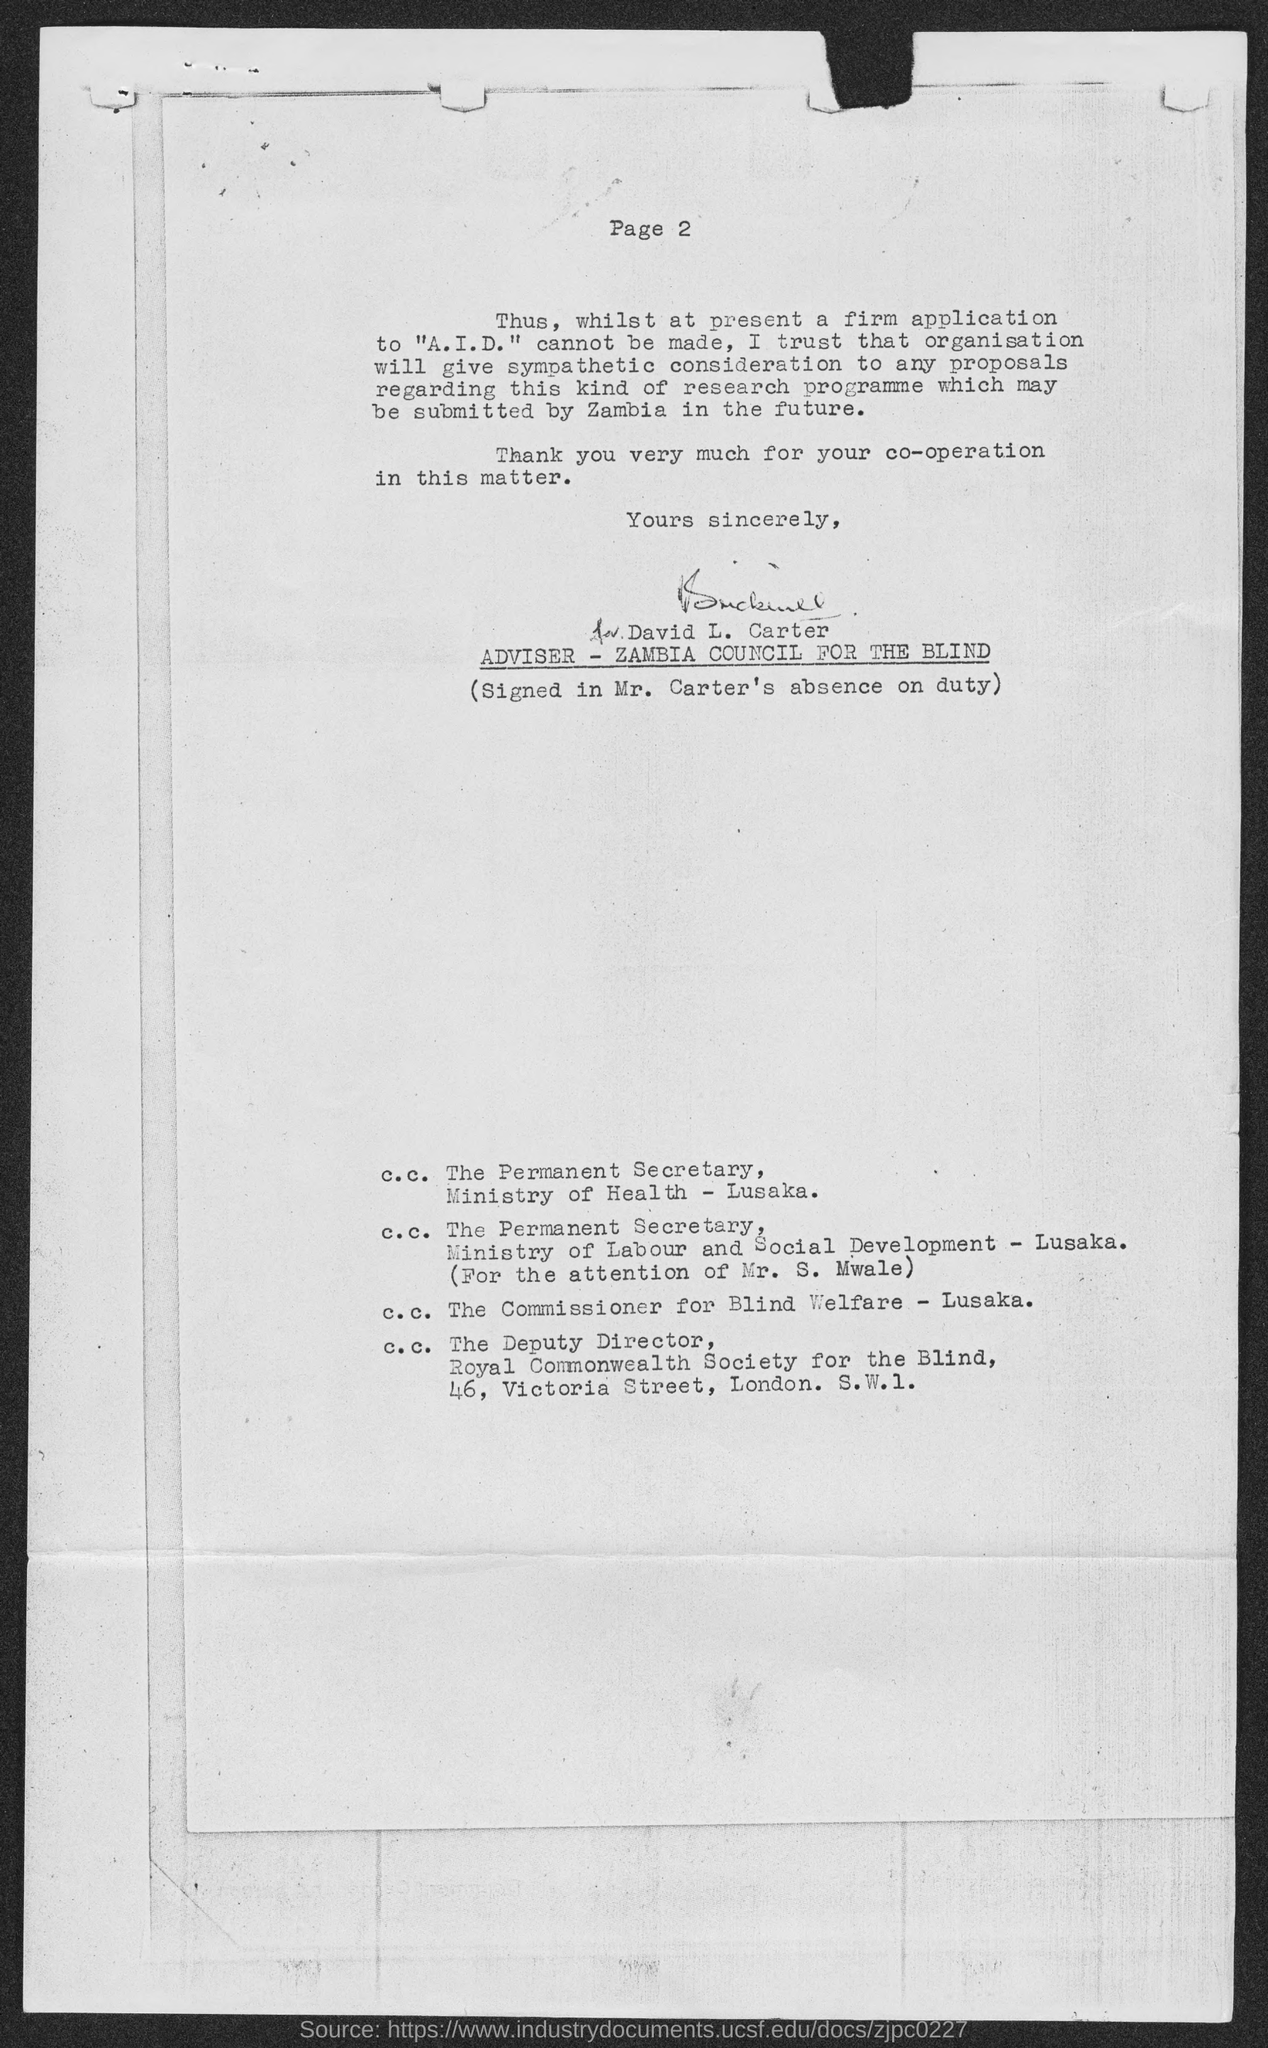Identify some key points in this picture. What page number is mentioned in this document? 2... The Zambia Council for the Blind has an adviser named David L. Carter. 